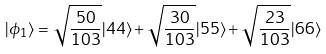Convert formula to latex. <formula><loc_0><loc_0><loc_500><loc_500>| \phi _ { 1 } \rangle = \sqrt { \frac { 5 0 } { 1 0 3 } } | 4 4 \rangle + \sqrt { \frac { 3 0 } { 1 0 3 } } | 5 5 \rangle + \sqrt { \frac { 2 3 } { 1 0 3 } } | 6 6 \rangle</formula> 